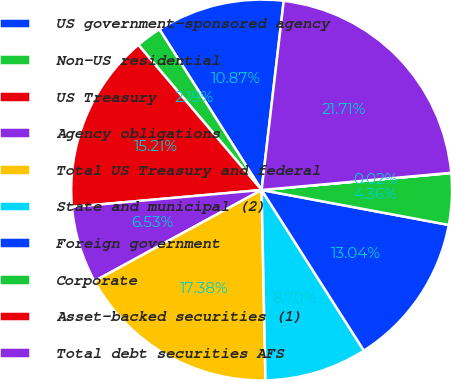Convert chart. <chart><loc_0><loc_0><loc_500><loc_500><pie_chart><fcel>US government-sponsored agency<fcel>Non-US residential<fcel>US Treasury<fcel>Agency obligations<fcel>Total US Treasury and federal<fcel>State and municipal (2)<fcel>Foreign government<fcel>Corporate<fcel>Asset-backed securities (1)<fcel>Total debt securities AFS<nl><fcel>10.87%<fcel>2.19%<fcel>15.21%<fcel>6.53%<fcel>17.38%<fcel>8.7%<fcel>13.04%<fcel>4.36%<fcel>0.02%<fcel>21.71%<nl></chart> 